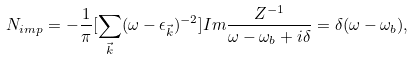Convert formula to latex. <formula><loc_0><loc_0><loc_500><loc_500>N _ { i m p } = - \frac { 1 } { \pi } [ \sum _ { \vec { k } } ( \omega - \epsilon _ { \vec { k } } ) ^ { - 2 } ] I m \frac { Z ^ { - 1 } } { \omega - \omega _ { b } + i \delta } = \delta ( \omega - \omega _ { b } ) ,</formula> 